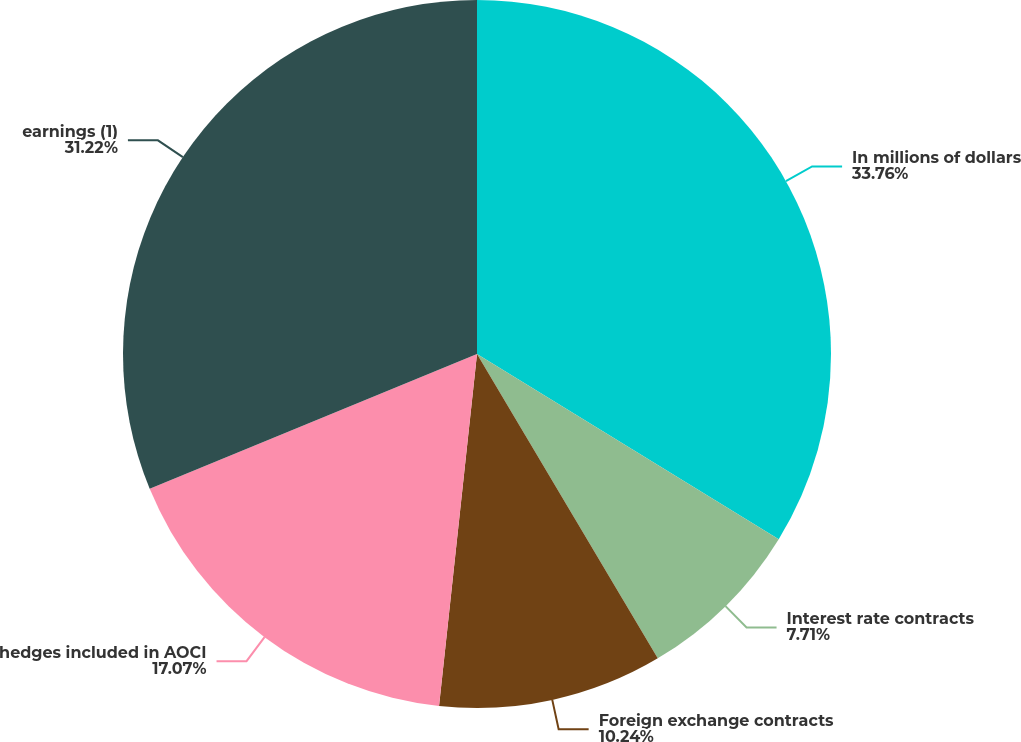Convert chart to OTSL. <chart><loc_0><loc_0><loc_500><loc_500><pie_chart><fcel>In millions of dollars<fcel>Interest rate contracts<fcel>Foreign exchange contracts<fcel>hedges included in AOCI<fcel>earnings (1)<nl><fcel>33.76%<fcel>7.71%<fcel>10.24%<fcel>17.07%<fcel>31.22%<nl></chart> 